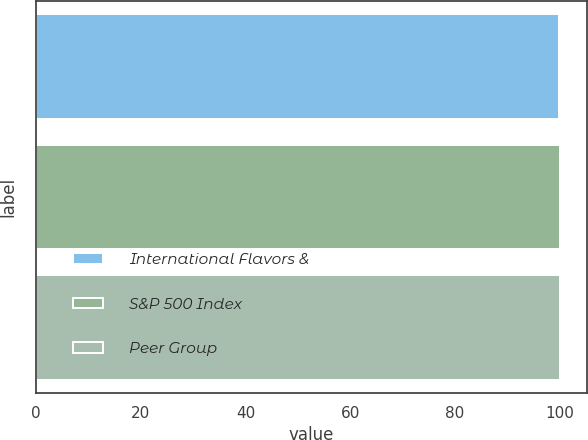Convert chart to OTSL. <chart><loc_0><loc_0><loc_500><loc_500><bar_chart><fcel>International Flavors &<fcel>S&P 500 Index<fcel>Peer Group<nl><fcel>100<fcel>100.1<fcel>100.2<nl></chart> 